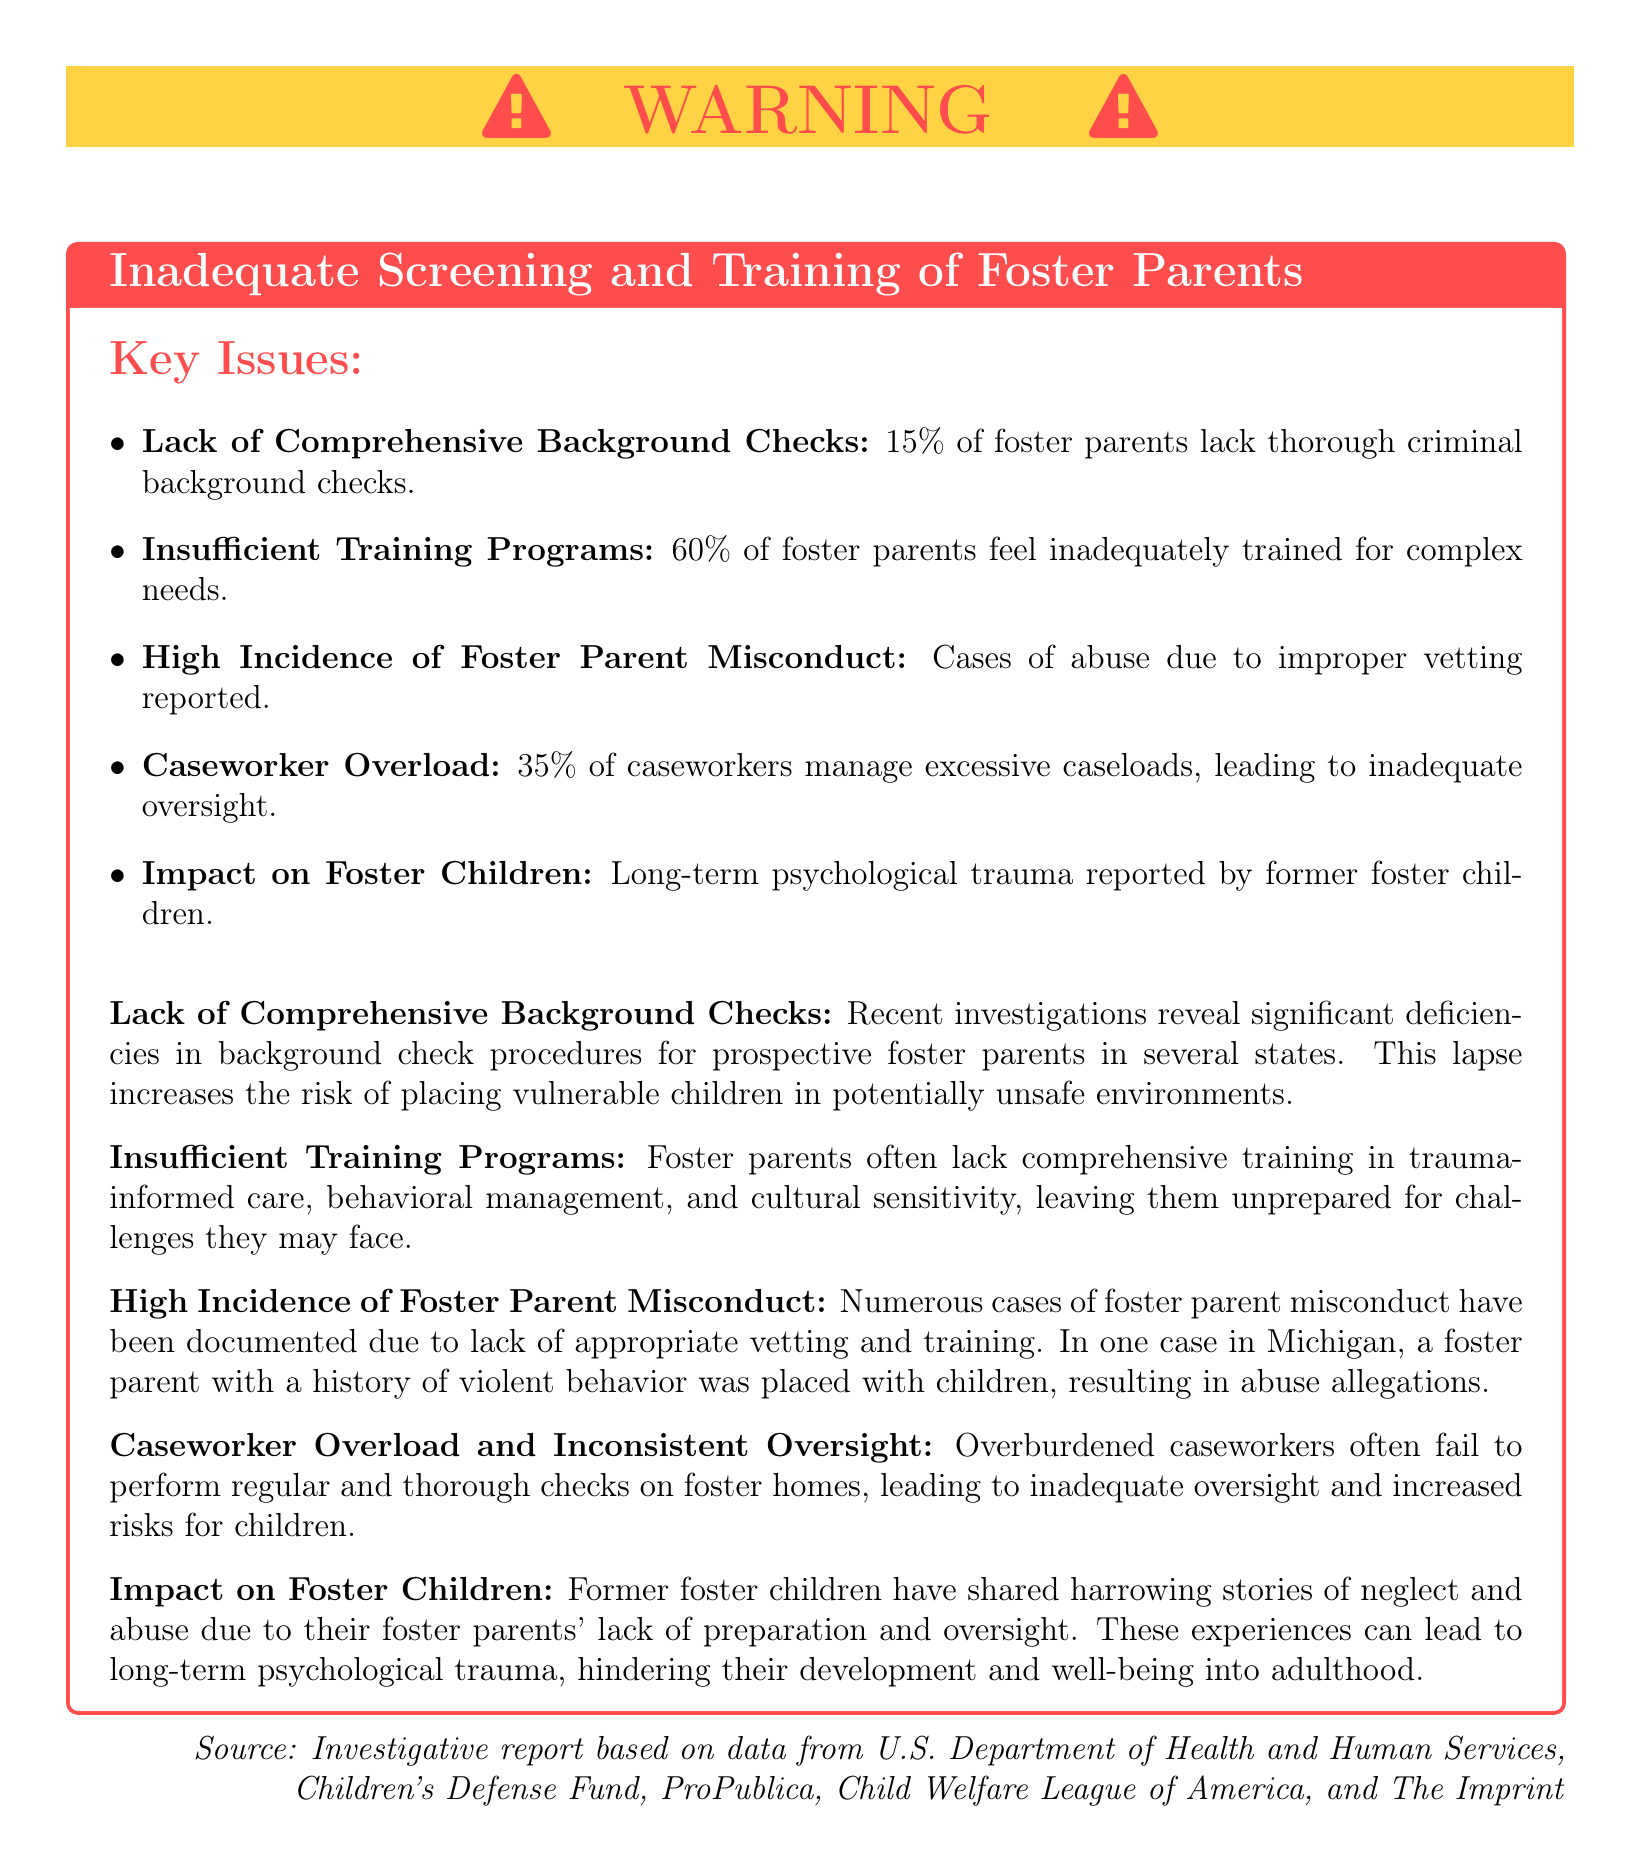What percentage of foster parents lack thorough criminal background checks? The percentage is explicitly stated in the key issues section of the document.
Answer: 15% What is the percentage of foster parents who feel inadequately trained? This information is also highlighted in the key issues section regarding training programs.
Answer: 60% What is reported by former foster children regarding their experiences? The document mentions the long-term effects faced by former foster children in the impact section.
Answer: Psychological trauma What is a consequence of high caseloads for caseworkers? The document discusses the consequences in the caseworker overload section.
Answer: Inadequate oversight Which state is mentioned in relation to a case of foster parent misconduct? The document refers to a specific case when discussing misconduct.
Answer: Michigan What type of training do foster parents often lack? The type of training that is lacking is specified in the section on insufficient training programs.
Answer: Trauma-informed care What is stated about the adequacy of background checks for foster parents? The issue is underscored in the first bullet point of the key issues section.
Answer: Significant deficiencies What is the main color of the warning label background? The color of the warning label is described at the start of the document.
Answer: Yellow 